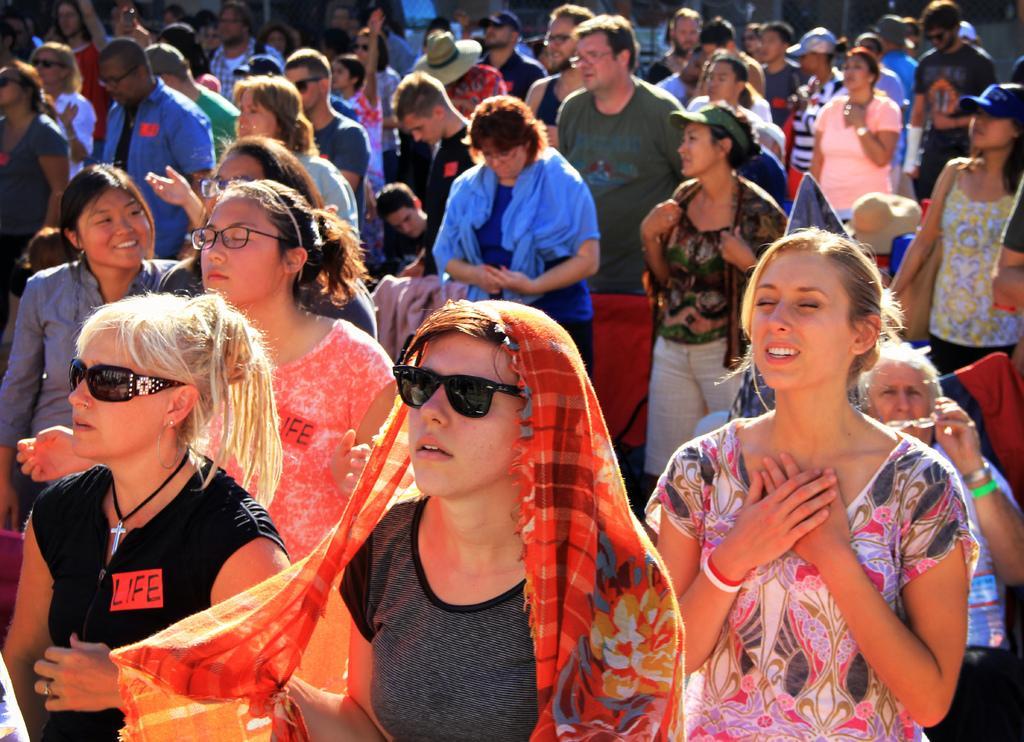In one or two sentences, can you explain what this image depicts? In this picture I can see few people are standing few of them wore spectacles and I can see few of them wore sunglasses and few wore caps on their heads. 